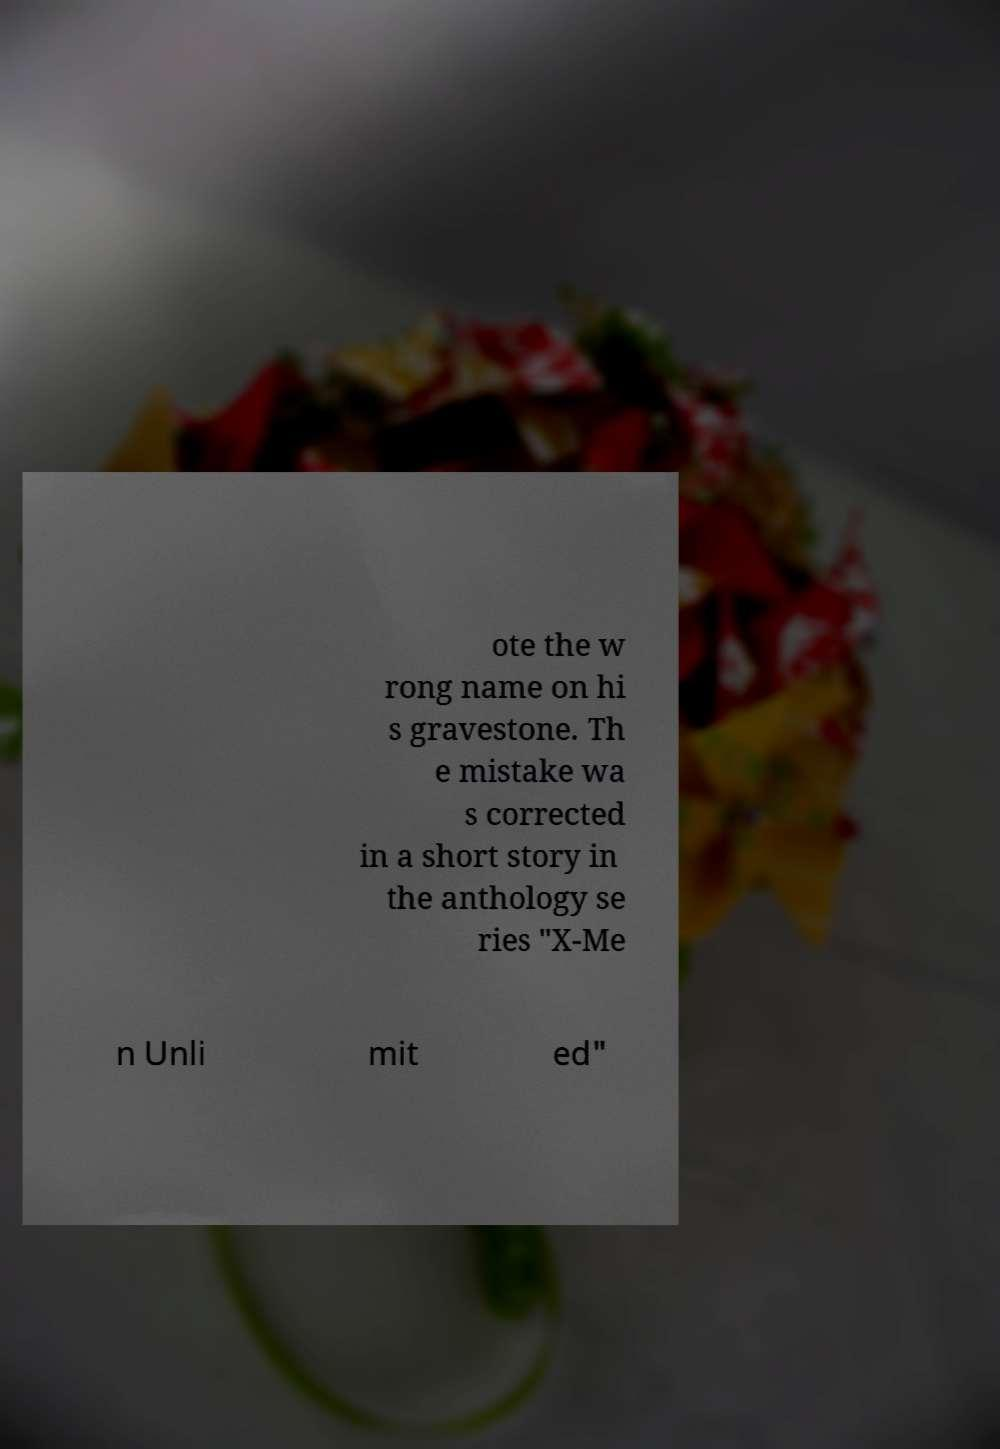For documentation purposes, I need the text within this image transcribed. Could you provide that? ote the w rong name on hi s gravestone. Th e mistake wa s corrected in a short story in the anthology se ries "X-Me n Unli mit ed" 